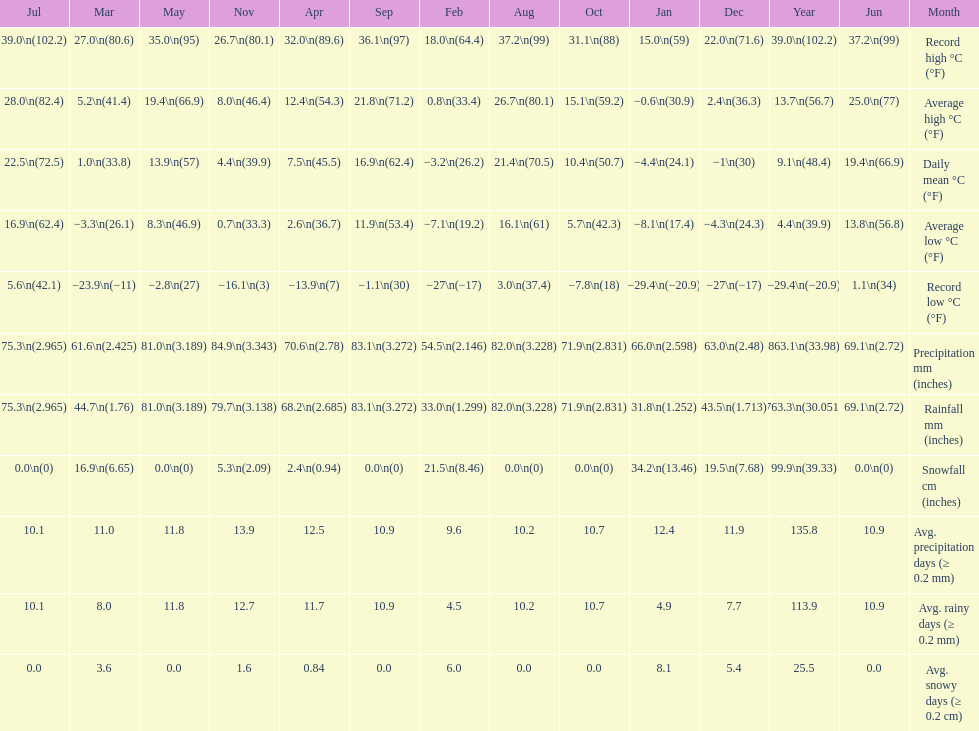How many months had a record high of over 15.0 degrees? 11. 